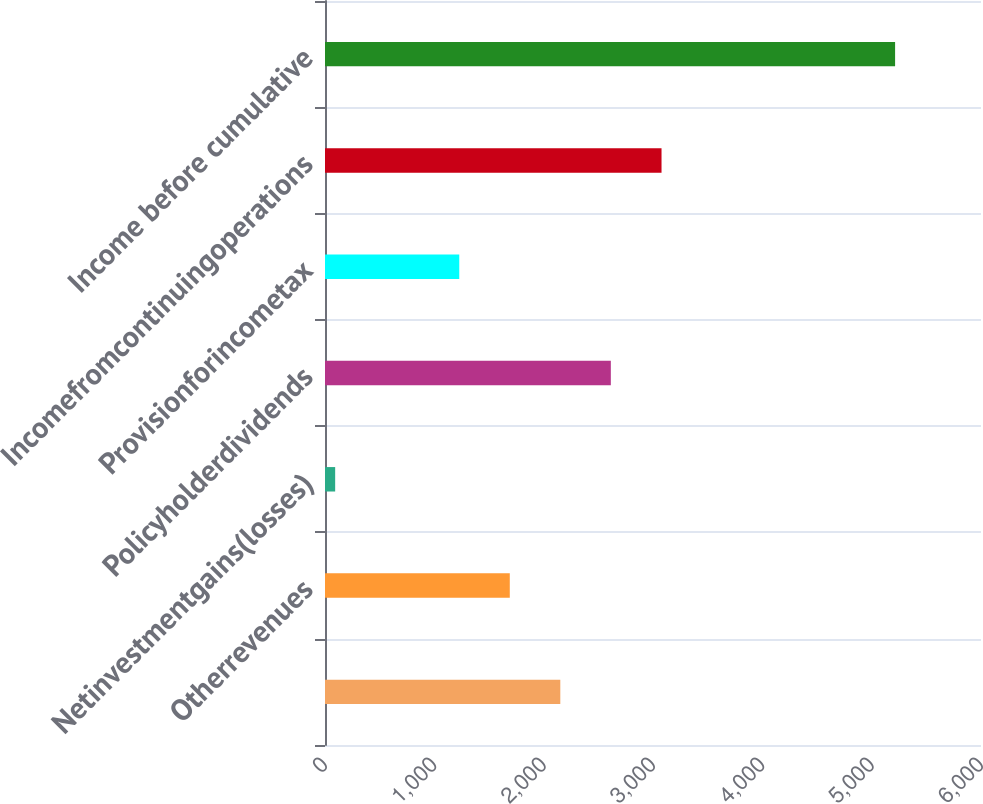Convert chart to OTSL. <chart><loc_0><loc_0><loc_500><loc_500><bar_chart><ecel><fcel>Otherrevenues<fcel>Netinvestmentgains(losses)<fcel>Policyholderdividends<fcel>Provisionforincometax<fcel>Incomefromcontinuingoperations<fcel>Income before cumulative<nl><fcel>2152.2<fcel>1690.1<fcel>93<fcel>2614.3<fcel>1228<fcel>3078<fcel>5214.3<nl></chart> 